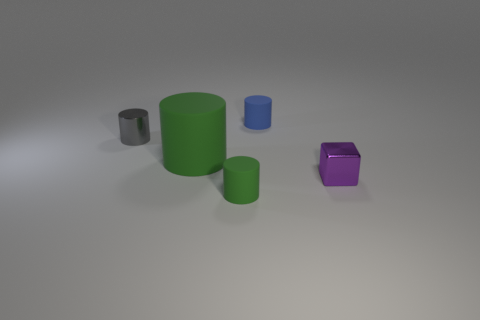Are the small blue thing and the small cylinder in front of the gray metal cylinder made of the same material?
Give a very brief answer. Yes. There is a rubber object behind the gray cylinder; is there a gray cylinder that is to the right of it?
Offer a terse response. No. There is a tiny blue object that is the same shape as the big rubber object; what is its material?
Offer a very short reply. Rubber. What number of small matte cylinders are in front of the small rubber cylinder that is on the right side of the small green rubber cylinder?
Provide a succinct answer. 1. Are there any other things of the same color as the small metallic cube?
Offer a terse response. No. How many objects are tiny purple metallic cylinders or things left of the tiny green rubber object?
Provide a succinct answer. 2. What is the tiny cylinder right of the tiny matte thing that is in front of the tiny metallic object that is right of the big green cylinder made of?
Provide a succinct answer. Rubber. What is the size of the cylinder that is made of the same material as the small cube?
Your answer should be very brief. Small. There is a rubber cylinder in front of the metal thing right of the tiny blue rubber thing; what color is it?
Offer a very short reply. Green. How many small cyan cubes are made of the same material as the tiny blue object?
Offer a very short reply. 0. 